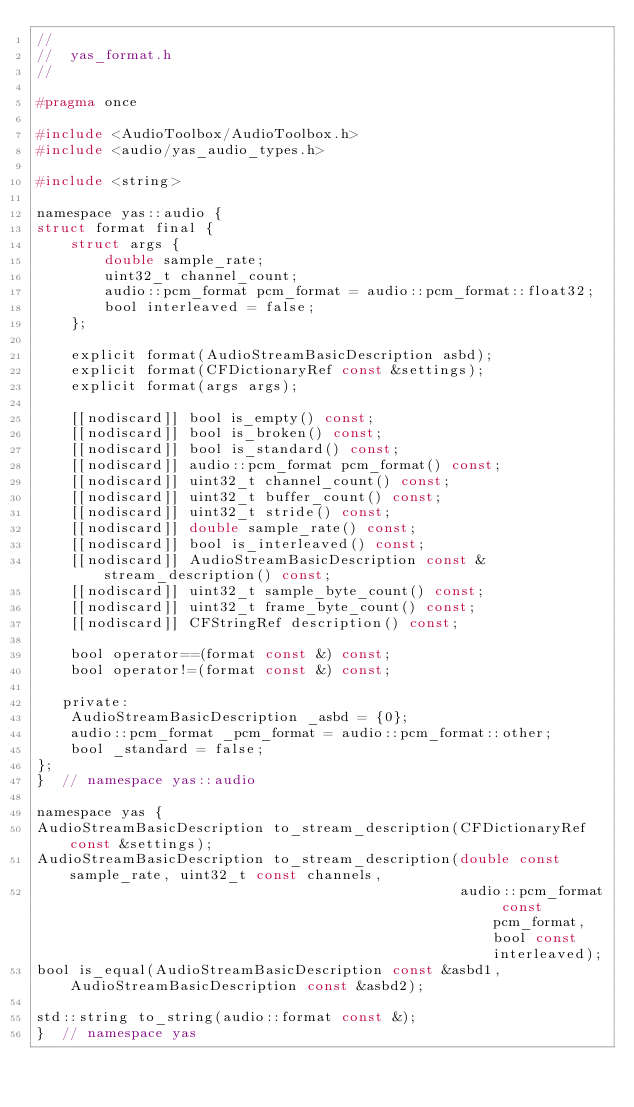Convert code to text. <code><loc_0><loc_0><loc_500><loc_500><_C_>//
//  yas_format.h
//

#pragma once

#include <AudioToolbox/AudioToolbox.h>
#include <audio/yas_audio_types.h>

#include <string>

namespace yas::audio {
struct format final {
    struct args {
        double sample_rate;
        uint32_t channel_count;
        audio::pcm_format pcm_format = audio::pcm_format::float32;
        bool interleaved = false;
    };

    explicit format(AudioStreamBasicDescription asbd);
    explicit format(CFDictionaryRef const &settings);
    explicit format(args args);

    [[nodiscard]] bool is_empty() const;
    [[nodiscard]] bool is_broken() const;
    [[nodiscard]] bool is_standard() const;
    [[nodiscard]] audio::pcm_format pcm_format() const;
    [[nodiscard]] uint32_t channel_count() const;
    [[nodiscard]] uint32_t buffer_count() const;
    [[nodiscard]] uint32_t stride() const;
    [[nodiscard]] double sample_rate() const;
    [[nodiscard]] bool is_interleaved() const;
    [[nodiscard]] AudioStreamBasicDescription const &stream_description() const;
    [[nodiscard]] uint32_t sample_byte_count() const;
    [[nodiscard]] uint32_t frame_byte_count() const;
    [[nodiscard]] CFStringRef description() const;

    bool operator==(format const &) const;
    bool operator!=(format const &) const;

   private:
    AudioStreamBasicDescription _asbd = {0};
    audio::pcm_format _pcm_format = audio::pcm_format::other;
    bool _standard = false;
};
}  // namespace yas::audio

namespace yas {
AudioStreamBasicDescription to_stream_description(CFDictionaryRef const &settings);
AudioStreamBasicDescription to_stream_description(double const sample_rate, uint32_t const channels,
                                                  audio::pcm_format const pcm_format, bool const interleaved);
bool is_equal(AudioStreamBasicDescription const &asbd1, AudioStreamBasicDescription const &asbd2);

std::string to_string(audio::format const &);
}  // namespace yas
</code> 